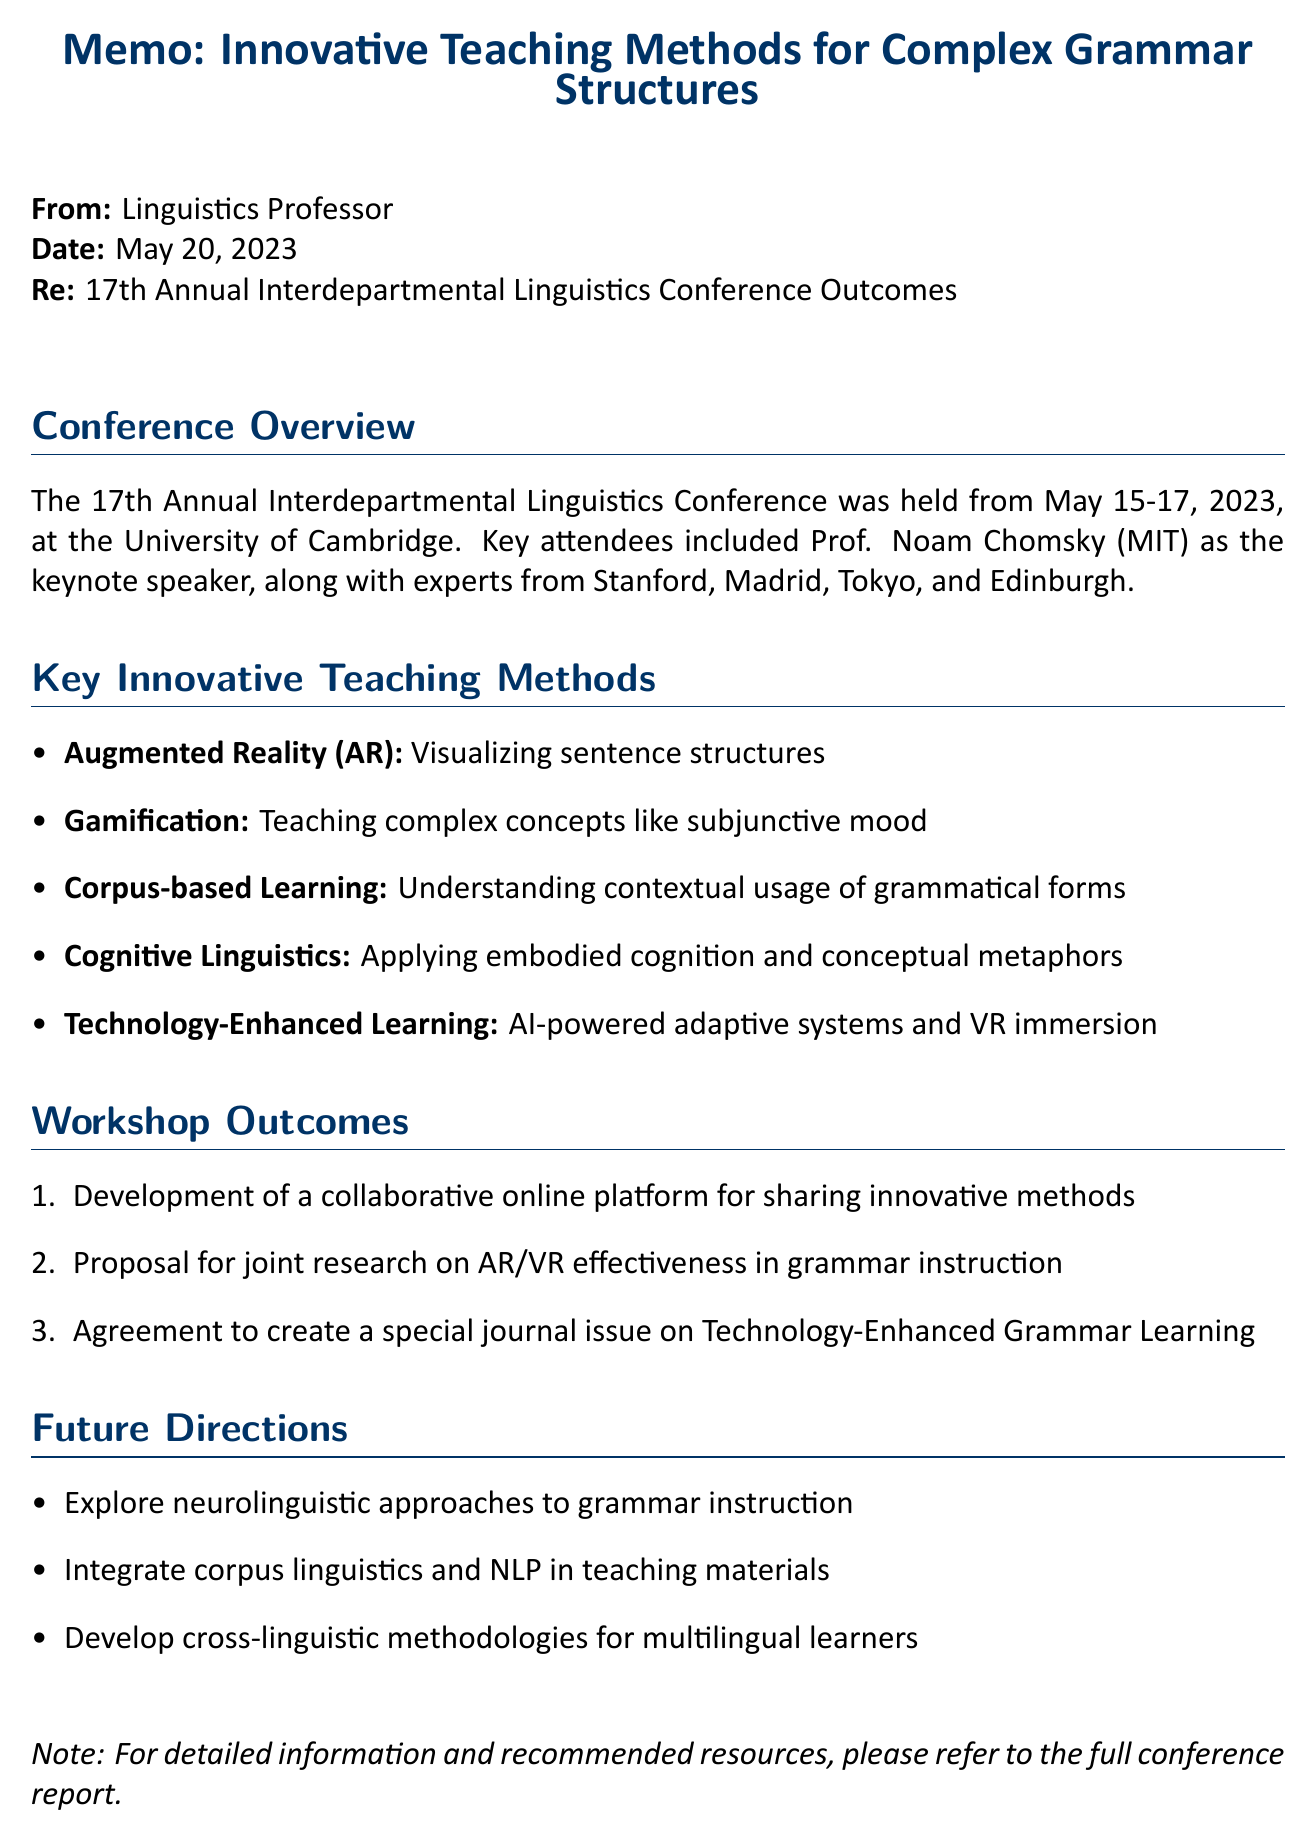What is the name of the conference? The name of the conference is stated at the beginning of the memo.
Answer: 17th Annual Interdepartmental Linguistics Conference Who was the keynote speaker? The keynote speaker is mentioned in the list of attendees.
Answer: Prof. Noam Chomsky What are two methods discussed for teaching complex grammar structures? The key innovative teaching methods are listed in the document.
Answer: Augmented Reality, Gamification How many days did the conference last? The duration of the conference is specified in the conference details section.
Answer: Three days What is one outcome from the workshop? The outcomes of the workshop are enumerated in the memo.
Answer: Development of a collaborative online platform for sharing innovative methods Which department hosted the conference? The venue provided in the document indicates the hosting department.
Answer: Faculty of Modern and Medieval Languages and Linguistics 